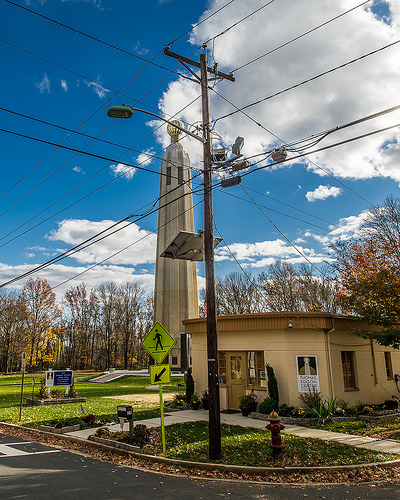<image>
Is the pole behind the building? No. The pole is not behind the building. From this viewpoint, the pole appears to be positioned elsewhere in the scene. 